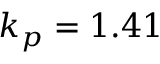<formula> <loc_0><loc_0><loc_500><loc_500>k _ { p } = 1 . 4 1</formula> 